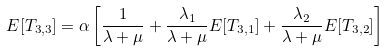Convert formula to latex. <formula><loc_0><loc_0><loc_500><loc_500>E [ T _ { 3 , 3 } ] = \alpha \left [ \frac { 1 } { \lambda + \mu } + \frac { \lambda _ { 1 } } { \lambda + \mu } E [ T _ { 3 , 1 } ] + \frac { \lambda _ { 2 } } { \lambda + \mu } E [ T _ { 3 , 2 } ] \right ]</formula> 